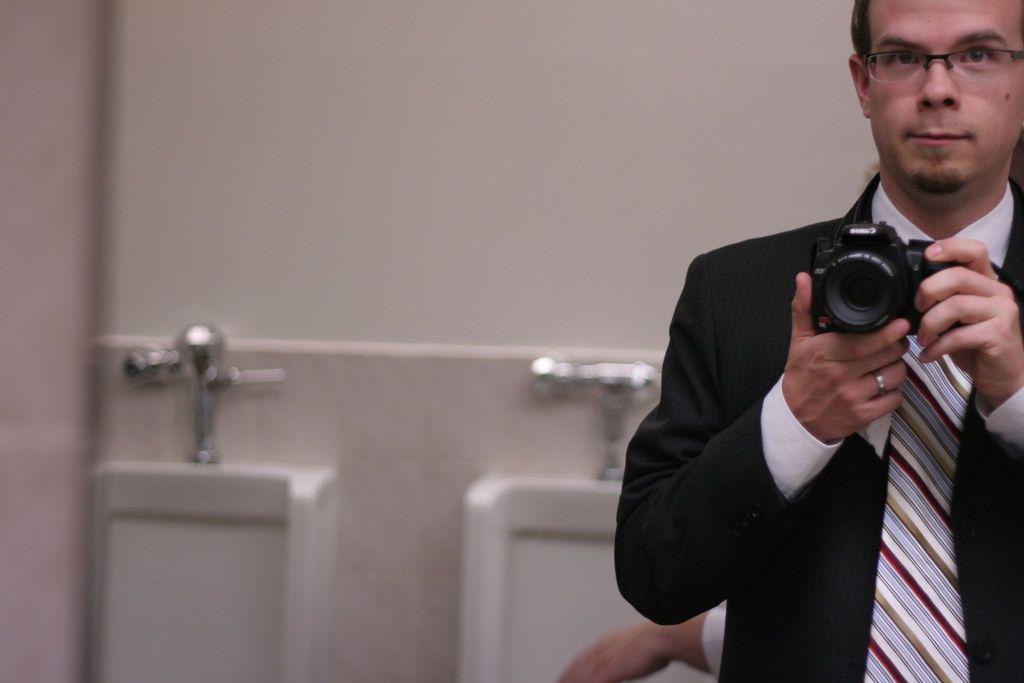In one or two sentences, can you explain what this image depicts? A man with a black color blazer , white shirt and with a striped tie clicking a picture holding the camera in his hand and at the back ground there is a person. 